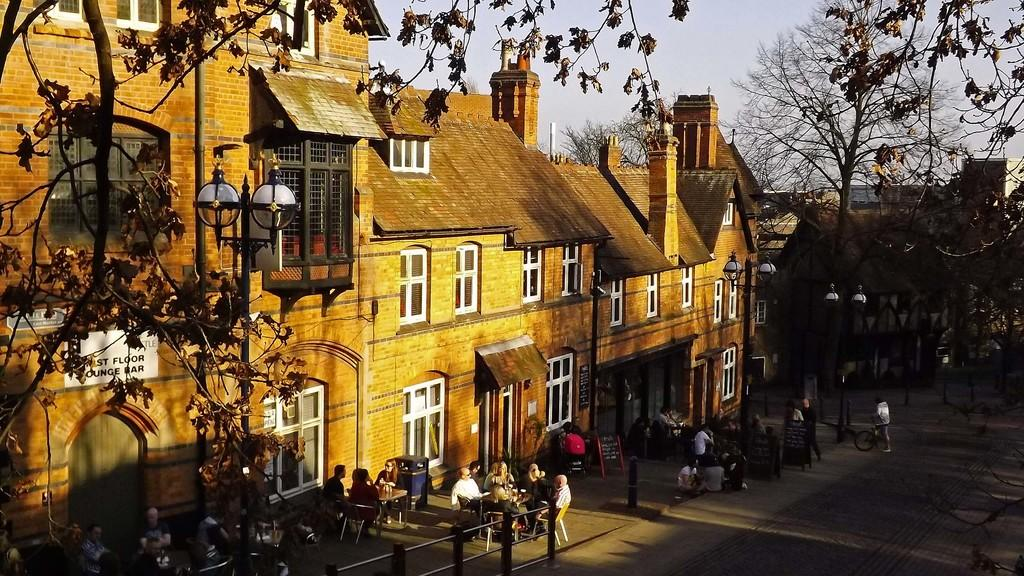What type of structures can be seen in the image? There are buildings in the image. What architectural features can be observed on the buildings? There are windows visible on the buildings. What type of lighting is present in the image? There is a streetlamp in the image. What type of vegetation is present in the image? There are trees in the image. What type of activity is happening in the image? There are people walking in the image. What mode of transportation can be seen in the image? There is a bicycle in the image. What part of the natural environment is visible in the image? The sky is visible in the image. What type of week is being celebrated in the image? There is no indication of a week being celebrated in the image. What type of apparatus is being used to pull the bicycle in the image? There is no apparatus being used to pull the bicycle in the image; it appears to be stationary. 